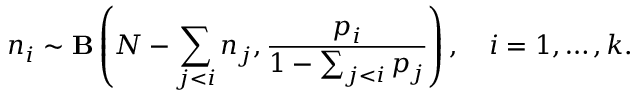<formula> <loc_0><loc_0><loc_500><loc_500>n _ { i } \sim { B } \left ( N - \sum _ { j < i } n _ { j } , \frac { p _ { i } } { 1 - \sum _ { j < i } p _ { j } } \right ) , \quad i = 1 , \dots , k .</formula> 